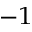Convert formula to latex. <formula><loc_0><loc_0><loc_500><loc_500>^ { - 1 }</formula> 